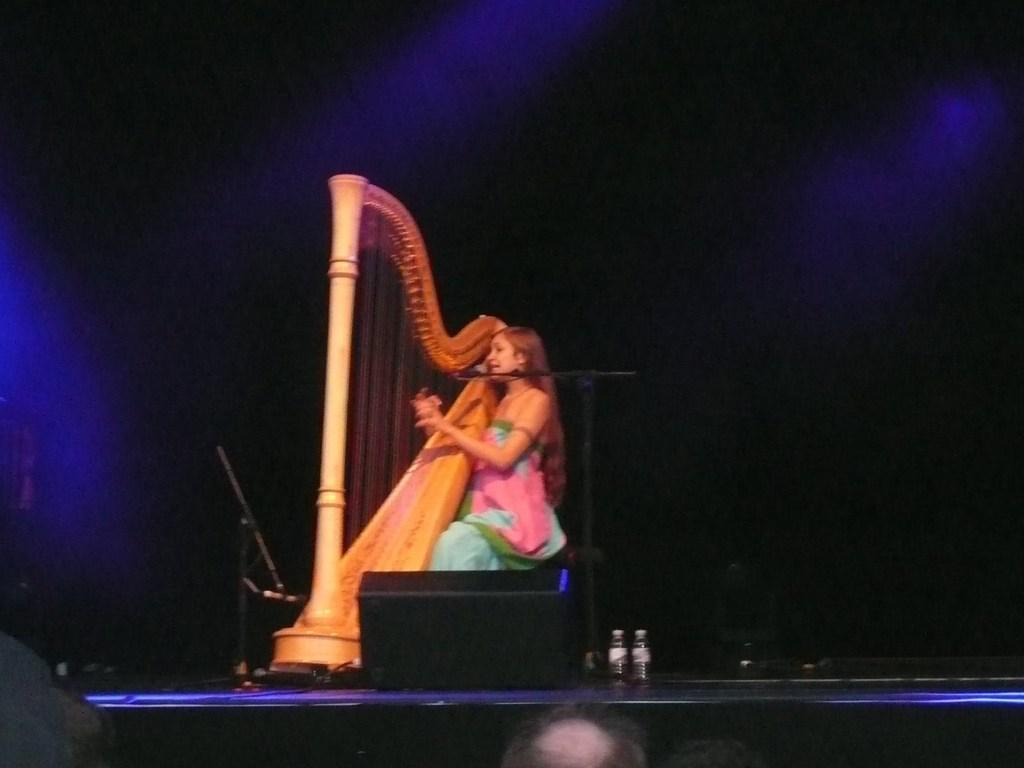What is the lady in the image doing? The lady in the image is playing a musical instrument. What objects are present in the image that might be used for amplifying sound? There are microphones (mics) in the image. What type of containers can be seen in the image? There are bottles in the image. How would you describe the lighting in the image? The background of the image is dark. Can you see any deer in the image? No, there are no deer present in the image. What is the cause of the musical instrument's sound in the image? The cause of the musical instrument's sound is not visible in the image, but it is likely due to the lady playing it. 